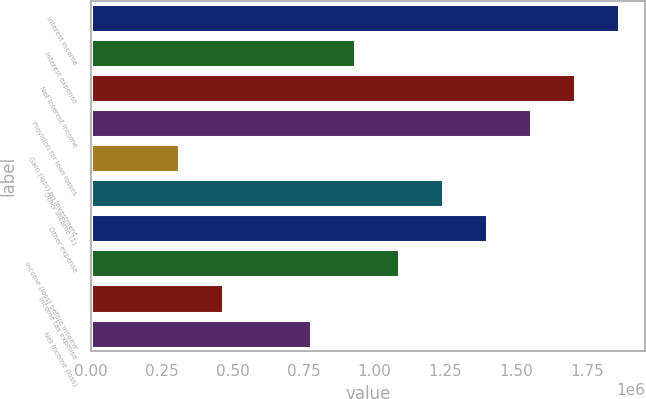Convert chart to OTSL. <chart><loc_0><loc_0><loc_500><loc_500><bar_chart><fcel>Interest income<fcel>Interest expense<fcel>Net interest income<fcel>Provision for loan losses<fcel>Gain (loss) on investment<fcel>Other income (1)<fcel>Other expense<fcel>Income (loss) before income<fcel>Income tax expense<fcel>Net income (loss)<nl><fcel>1.86214e+06<fcel>931069<fcel>1.70696e+06<fcel>1.55178e+06<fcel>310357<fcel>1.24143e+06<fcel>1.3966e+06<fcel>1.08625e+06<fcel>465535<fcel>775891<nl></chart> 